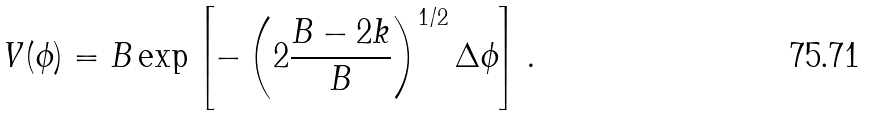<formula> <loc_0><loc_0><loc_500><loc_500>V ( \phi ) = B \exp \left [ - \left ( 2 \frac { B - 2 k } { B } \right ) ^ { 1 / 2 } \Delta \phi \right ] .</formula> 